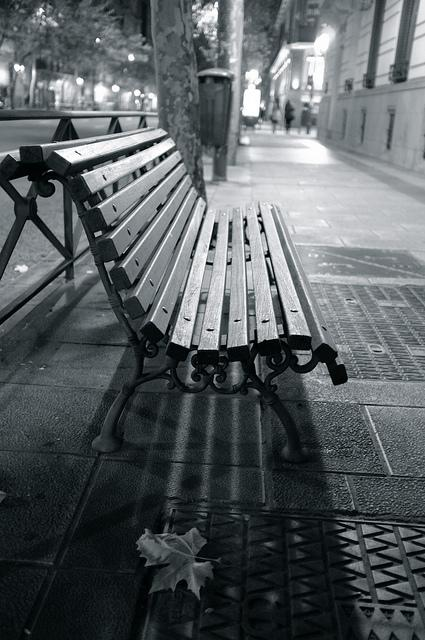In what area is this chair located?

Choices:
A) park
B) playground
C) side walk
D) backyard side walk 